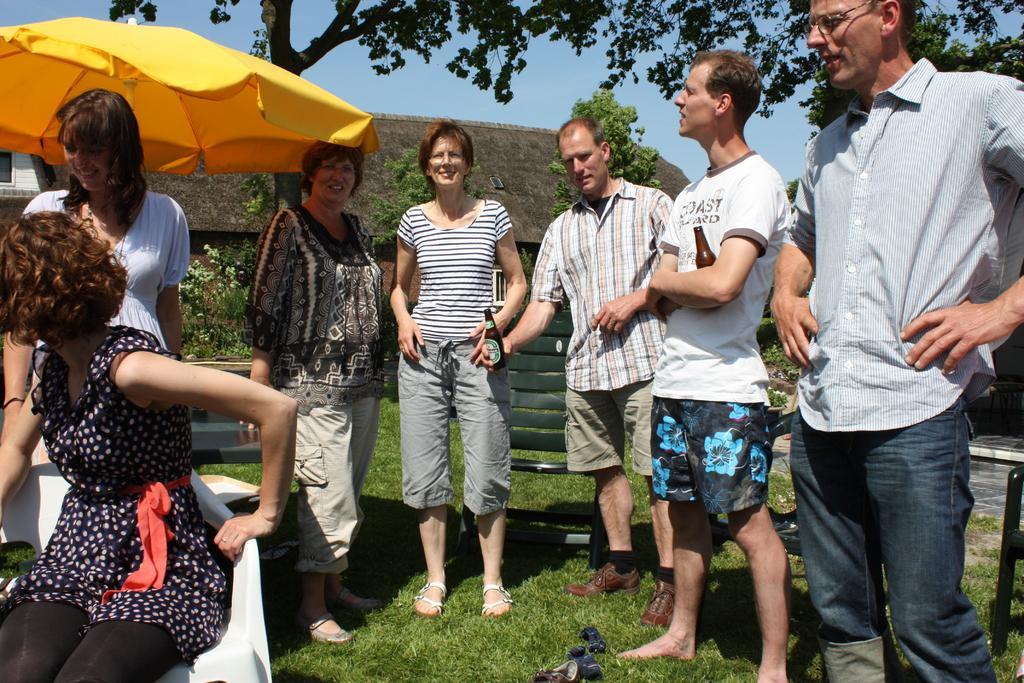In one or two sentences, can you explain what this image depicts? In this picture I can see there are few people standing and there is a woman sitting in the chair on to left and in the backdrop there are trees, buildings and the sky is clear. 